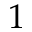Convert formula to latex. <formula><loc_0><loc_0><loc_500><loc_500>1</formula> 